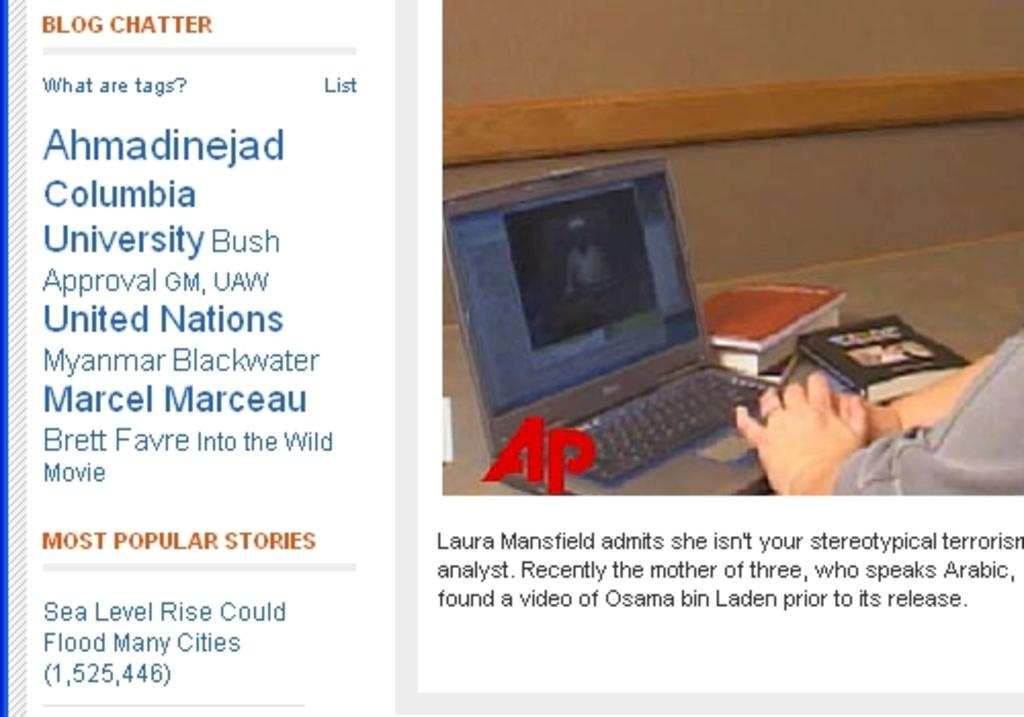What can be found on the left side of the image? There is text on the left side of the image. What is located on the right side of the image? There is a laptop on the right side of the image. What other objects are present in the image? There are books in the image. Where are the human hands located in the image? Human hands are visible in the right-hand side bottom bottom side of the image. How many girls are present in the image? There is no mention of girls in the provided facts, so we cannot determine the number of girls in the image. What is the distance between the laptop and the text in the image? The provided facts do not give information about the distance between the laptop and the text, so we cannot determine the distance. 